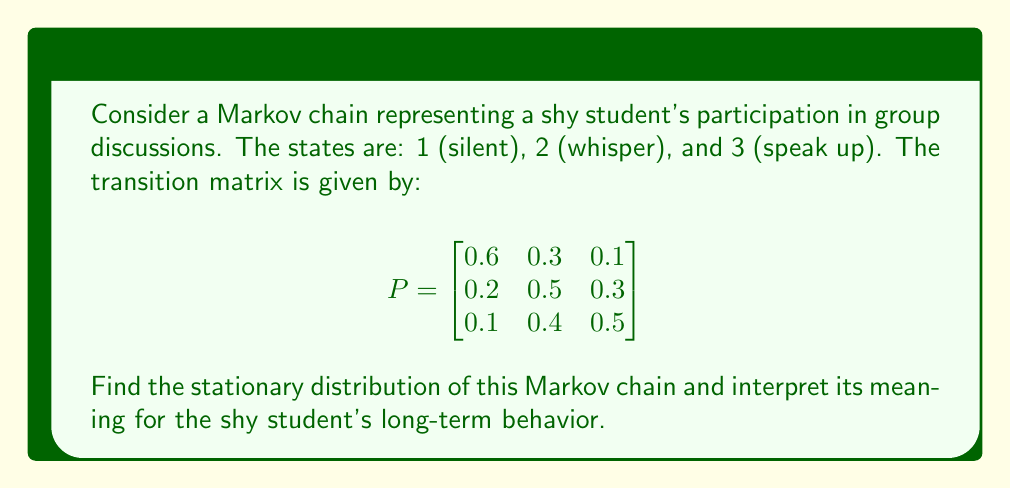Can you answer this question? To find the stationary distribution $\pi = (\pi_1, \pi_2, \pi_3)$, we need to solve the equation $\pi P = \pi$ subject to the constraint $\pi_1 + \pi_2 + \pi_3 = 1$.

Step 1: Set up the system of equations:
$$\begin{align}
0.6\pi_1 + 0.2\pi_2 + 0.1\pi_3 &= \pi_1 \\
0.3\pi_1 + 0.5\pi_2 + 0.4\pi_3 &= \pi_2 \\
0.1\pi_1 + 0.3\pi_2 + 0.5\pi_3 &= \pi_3 \\
\pi_1 + \pi_2 + \pi_3 &= 1
\end{align}$$

Step 2: Simplify the equations:
$$\begin{align}
-0.4\pi_1 + 0.2\pi_2 + 0.1\pi_3 &= 0 \\
0.3\pi_1 - 0.5\pi_2 + 0.4\pi_3 &= 0 \\
0.1\pi_1 + 0.3\pi_2 - 0.5\pi_3 &= 0 \\
\pi_1 + \pi_2 + \pi_3 &= 1
\end{align}$$

Step 3: Solve the system of equations (using elimination or substitution):
$$\begin{align}
\pi_1 &= \frac{10}{37} \approx 0.2703 \\
\pi_2 &= \frac{15}{37} \approx 0.4054 \\
\pi_3 &= \frac{12}{37} \approx 0.3243
\end{align}$$

Step 4: Interpret the results:
The stationary distribution $\pi = (\frac{10}{37}, \frac{15}{37}, \frac{12}{37})$ represents the long-term probabilities of the shy student being in each state. In the long run:
- The student will be silent about 27.03% of the time
- The student will whisper about 40.54% of the time
- The student will speak up about 32.43% of the time

This suggests that, over time, the shy student will become more comfortable participating in group discussions, with a higher probability of whispering or speaking up compared to remaining silent.
Answer: $\pi = (\frac{10}{37}, \frac{15}{37}, \frac{12}{37})$ 